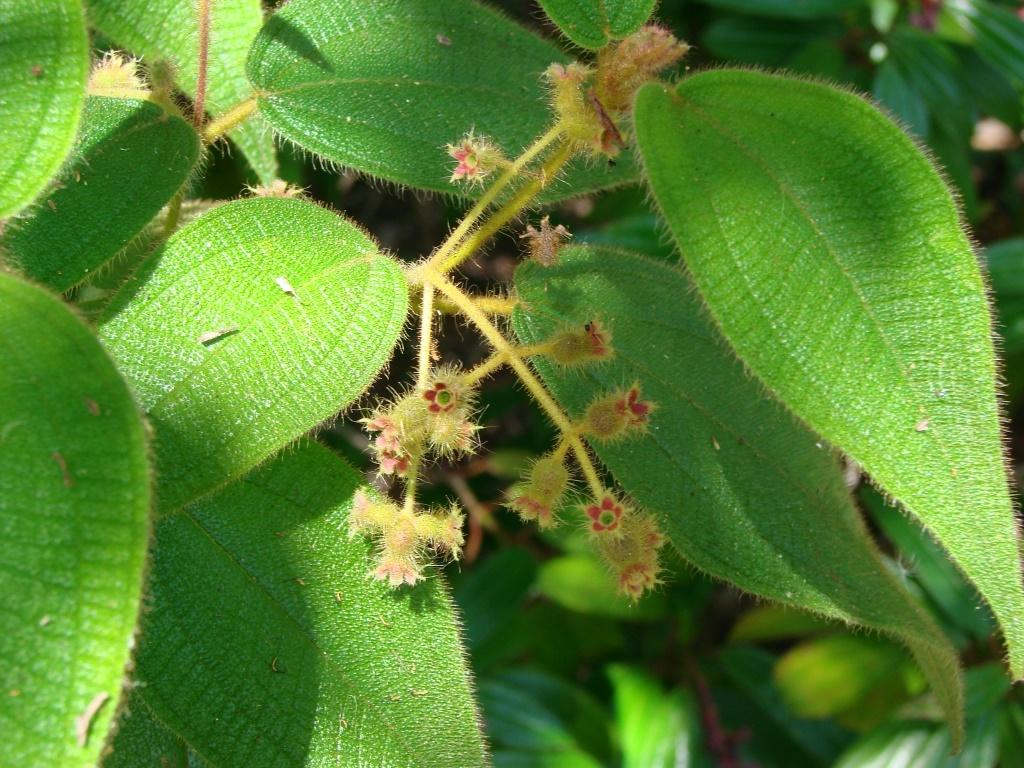What type of plant life can be seen in the image? There are leaves and flowers in the image. Can you describe the flowers in the image? The flowers in the image are not specified, but they are present alongside the leaves. What type of plane can be seen flying over the playground in the image? There is no plane or playground present in the image; it only features leaves and flowers. 